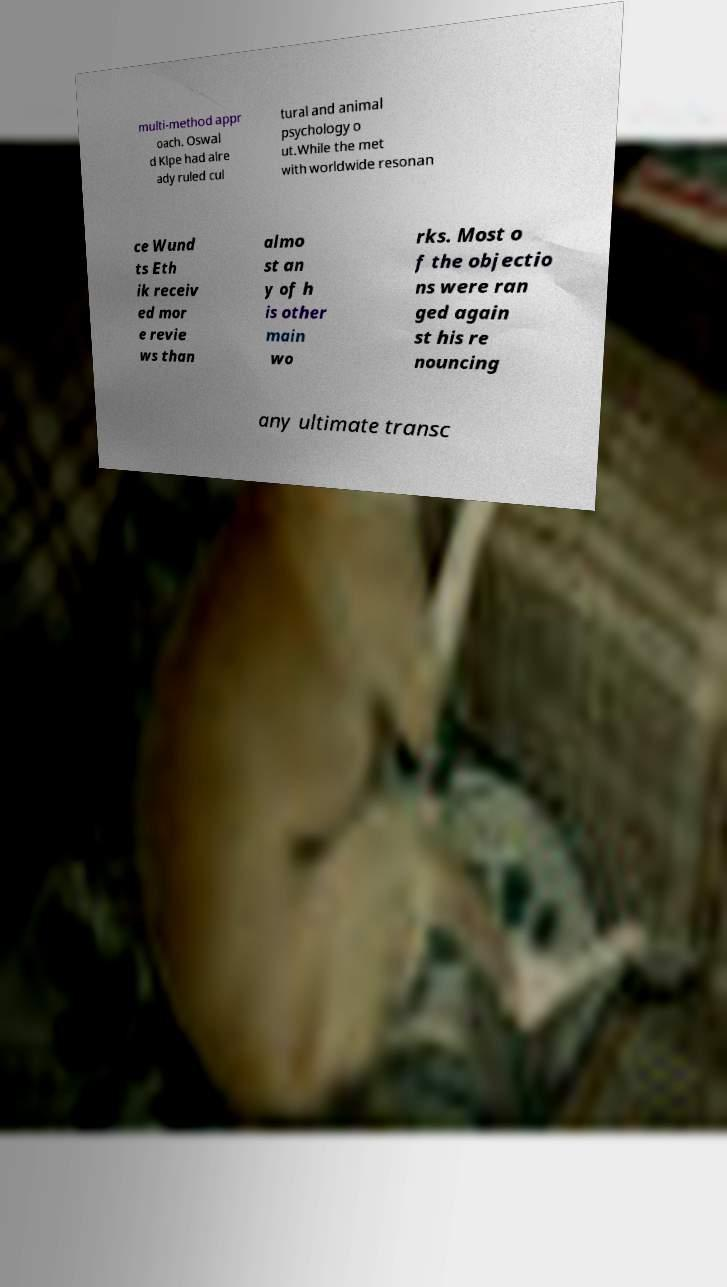There's text embedded in this image that I need extracted. Can you transcribe it verbatim? multi-method appr oach. Oswal d Klpe had alre ady ruled cul tural and animal psychology o ut.While the met with worldwide resonan ce Wund ts Eth ik receiv ed mor e revie ws than almo st an y of h is other main wo rks. Most o f the objectio ns were ran ged again st his re nouncing any ultimate transc 